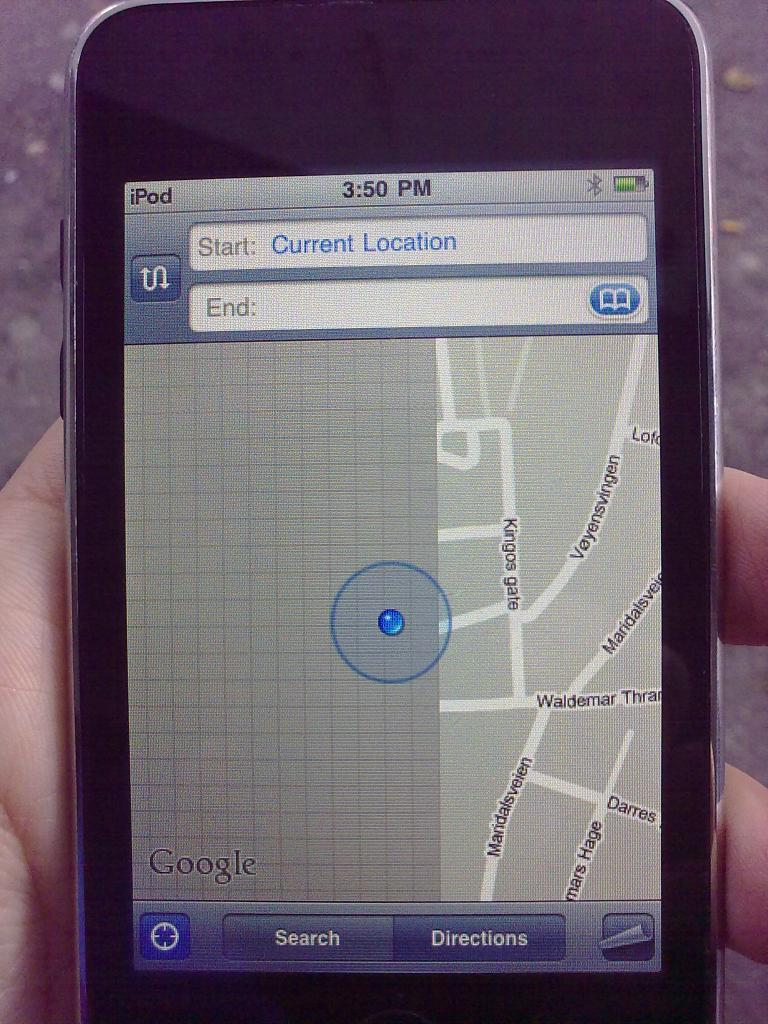<image>
Present a compact description of the photo's key features. a phone that has the time of 3:50 on it 